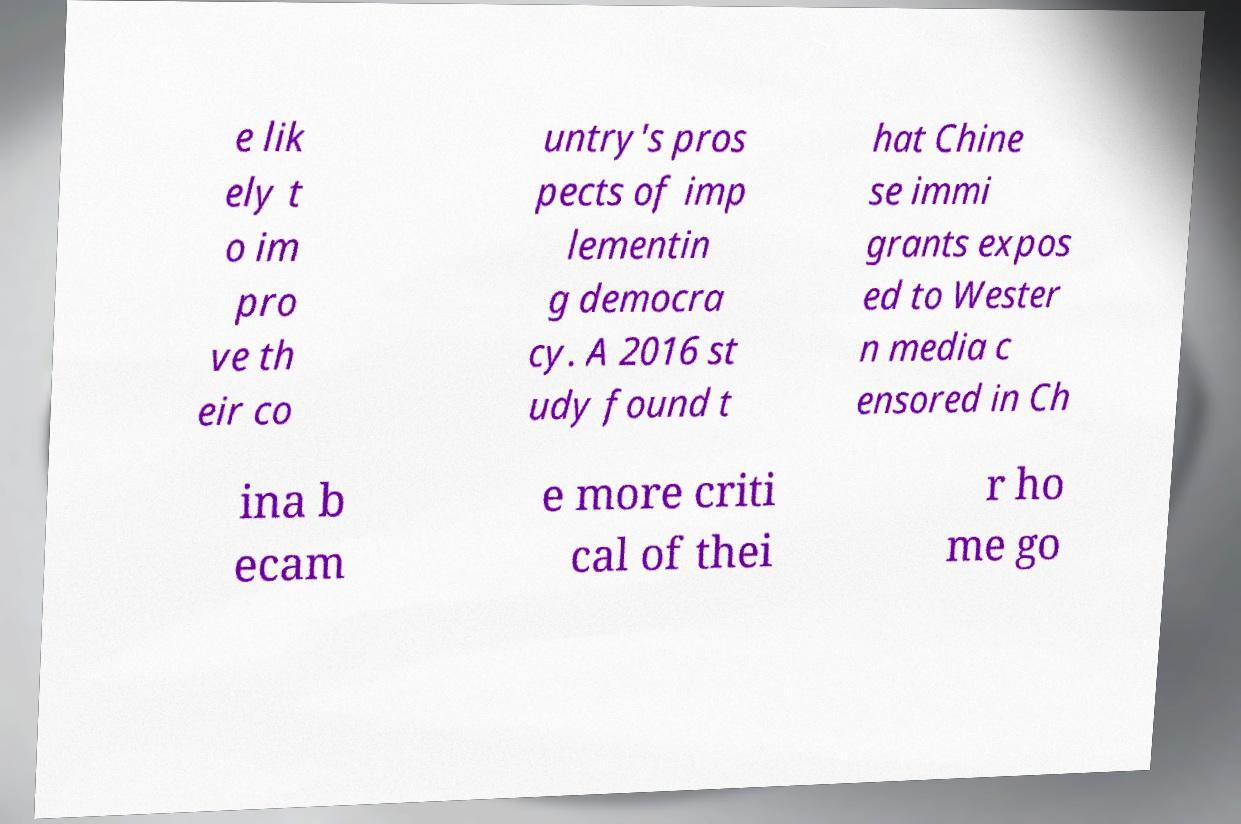Please read and relay the text visible in this image. What does it say? e lik ely t o im pro ve th eir co untry's pros pects of imp lementin g democra cy. A 2016 st udy found t hat Chine se immi grants expos ed to Wester n media c ensored in Ch ina b ecam e more criti cal of thei r ho me go 